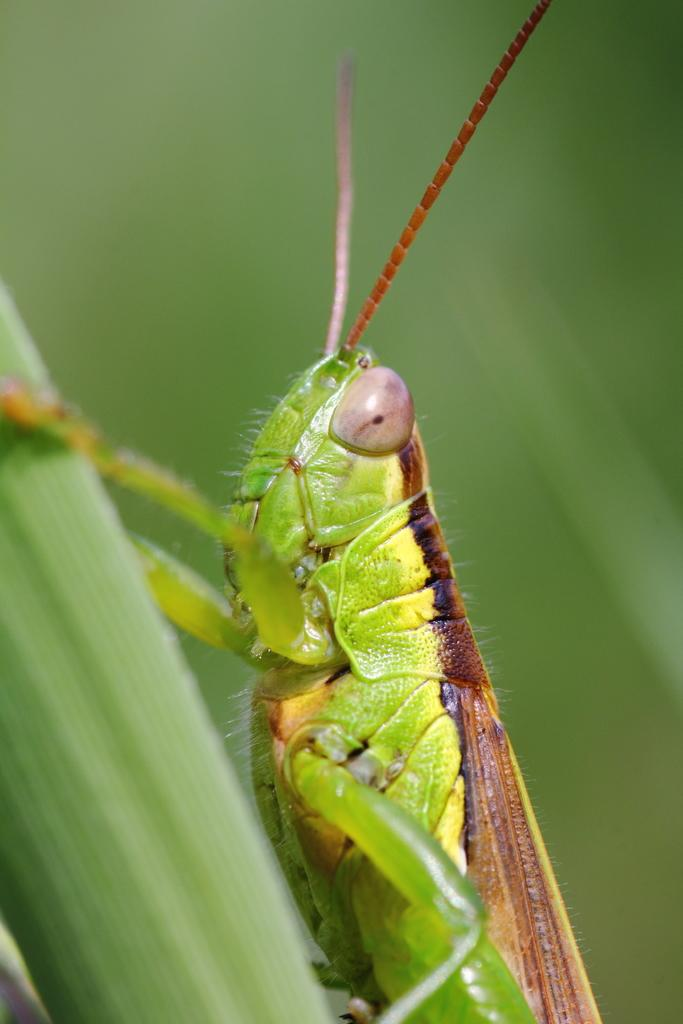What is the main subject of the image? There is a grasshopper in the image. Where is the grasshopper located? The grasshopper is on the grass. Can you describe the background of the image? The background of the image is blurred. What type of account does the grasshopper have in the image? There is no mention of an account in the image, as it features a grasshopper on the grass with a blurred background. 